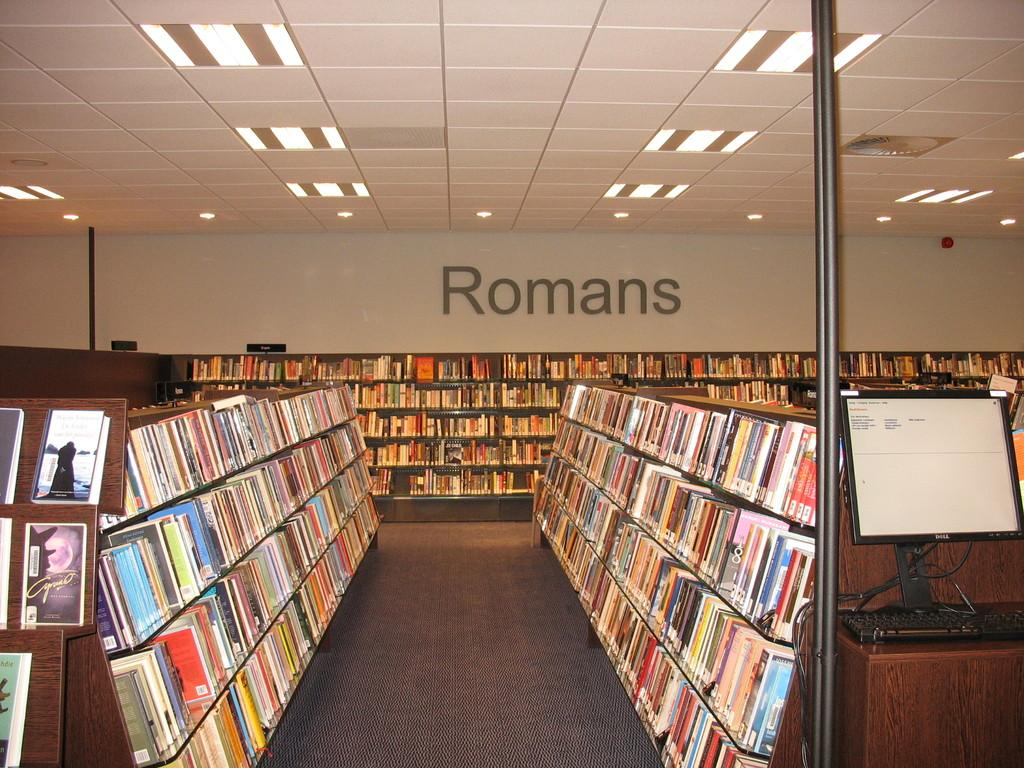<image>
Share a concise interpretation of the image provided. bookstore with word Romans in large letters on back wall above books 